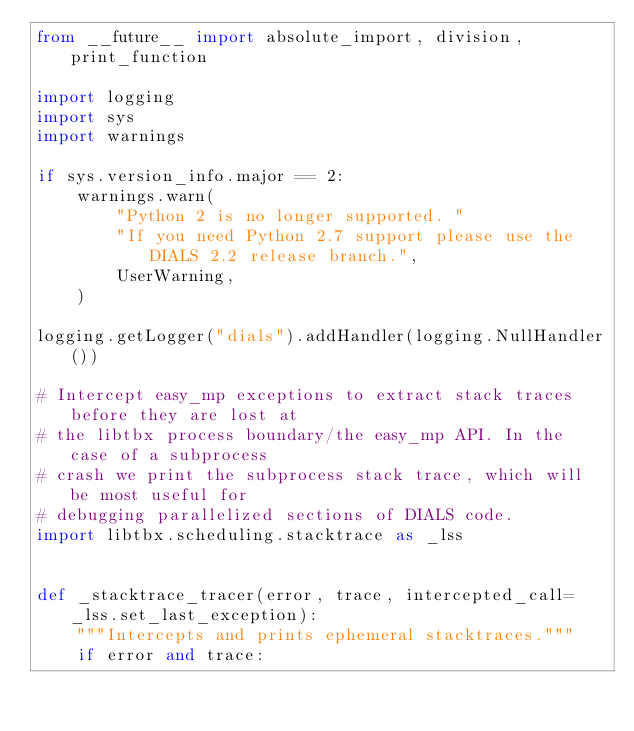Convert code to text. <code><loc_0><loc_0><loc_500><loc_500><_Python_>from __future__ import absolute_import, division, print_function

import logging
import sys
import warnings

if sys.version_info.major == 2:
    warnings.warn(
        "Python 2 is no longer supported. "
        "If you need Python 2.7 support please use the DIALS 2.2 release branch.",
        UserWarning,
    )

logging.getLogger("dials").addHandler(logging.NullHandler())

# Intercept easy_mp exceptions to extract stack traces before they are lost at
# the libtbx process boundary/the easy_mp API. In the case of a subprocess
# crash we print the subprocess stack trace, which will be most useful for
# debugging parallelized sections of DIALS code.
import libtbx.scheduling.stacktrace as _lss


def _stacktrace_tracer(error, trace, intercepted_call=_lss.set_last_exception):
    """Intercepts and prints ephemeral stacktraces."""
    if error and trace:</code> 